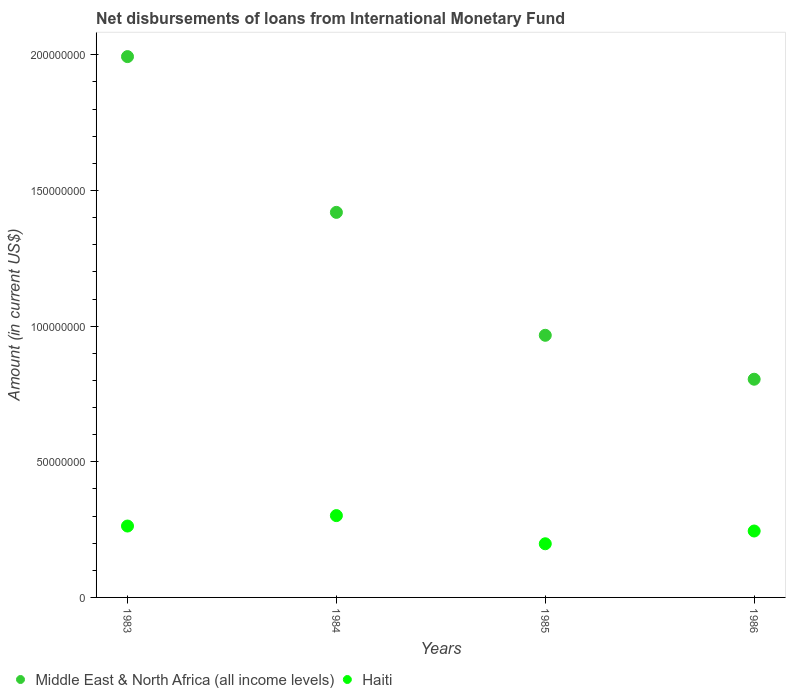Is the number of dotlines equal to the number of legend labels?
Keep it short and to the point. Yes. What is the amount of loans disbursed in Haiti in 1986?
Give a very brief answer. 2.45e+07. Across all years, what is the maximum amount of loans disbursed in Haiti?
Provide a short and direct response. 3.02e+07. Across all years, what is the minimum amount of loans disbursed in Haiti?
Offer a terse response. 1.98e+07. In which year was the amount of loans disbursed in Middle East & North Africa (all income levels) minimum?
Keep it short and to the point. 1986. What is the total amount of loans disbursed in Middle East & North Africa (all income levels) in the graph?
Make the answer very short. 5.18e+08. What is the difference between the amount of loans disbursed in Haiti in 1985 and that in 1986?
Offer a very short reply. -4.70e+06. What is the difference between the amount of loans disbursed in Middle East & North Africa (all income levels) in 1985 and the amount of loans disbursed in Haiti in 1983?
Offer a terse response. 7.03e+07. What is the average amount of loans disbursed in Haiti per year?
Provide a short and direct response. 2.52e+07. In the year 1985, what is the difference between the amount of loans disbursed in Middle East & North Africa (all income levels) and amount of loans disbursed in Haiti?
Provide a short and direct response. 7.68e+07. In how many years, is the amount of loans disbursed in Middle East & North Africa (all income levels) greater than 150000000 US$?
Provide a succinct answer. 1. What is the ratio of the amount of loans disbursed in Haiti in 1985 to that in 1986?
Provide a short and direct response. 0.81. Is the difference between the amount of loans disbursed in Middle East & North Africa (all income levels) in 1983 and 1985 greater than the difference between the amount of loans disbursed in Haiti in 1983 and 1985?
Make the answer very short. Yes. What is the difference between the highest and the second highest amount of loans disbursed in Middle East & North Africa (all income levels)?
Your answer should be very brief. 5.74e+07. What is the difference between the highest and the lowest amount of loans disbursed in Middle East & North Africa (all income levels)?
Keep it short and to the point. 1.19e+08. In how many years, is the amount of loans disbursed in Middle East & North Africa (all income levels) greater than the average amount of loans disbursed in Middle East & North Africa (all income levels) taken over all years?
Ensure brevity in your answer.  2. Is the amount of loans disbursed in Haiti strictly greater than the amount of loans disbursed in Middle East & North Africa (all income levels) over the years?
Provide a short and direct response. No. How many dotlines are there?
Your response must be concise. 2. Are the values on the major ticks of Y-axis written in scientific E-notation?
Provide a short and direct response. No. Where does the legend appear in the graph?
Your answer should be very brief. Bottom left. How are the legend labels stacked?
Provide a succinct answer. Horizontal. What is the title of the graph?
Keep it short and to the point. Net disbursements of loans from International Monetary Fund. What is the label or title of the Y-axis?
Your answer should be very brief. Amount (in current US$). What is the Amount (in current US$) of Middle East & North Africa (all income levels) in 1983?
Make the answer very short. 1.99e+08. What is the Amount (in current US$) of Haiti in 1983?
Give a very brief answer. 2.63e+07. What is the Amount (in current US$) in Middle East & North Africa (all income levels) in 1984?
Keep it short and to the point. 1.42e+08. What is the Amount (in current US$) of Haiti in 1984?
Your answer should be very brief. 3.02e+07. What is the Amount (in current US$) in Middle East & North Africa (all income levels) in 1985?
Your response must be concise. 9.66e+07. What is the Amount (in current US$) of Haiti in 1985?
Ensure brevity in your answer.  1.98e+07. What is the Amount (in current US$) of Middle East & North Africa (all income levels) in 1986?
Ensure brevity in your answer.  8.04e+07. What is the Amount (in current US$) of Haiti in 1986?
Provide a succinct answer. 2.45e+07. Across all years, what is the maximum Amount (in current US$) of Middle East & North Africa (all income levels)?
Offer a terse response. 1.99e+08. Across all years, what is the maximum Amount (in current US$) in Haiti?
Your answer should be compact. 3.02e+07. Across all years, what is the minimum Amount (in current US$) of Middle East & North Africa (all income levels)?
Make the answer very short. 8.04e+07. Across all years, what is the minimum Amount (in current US$) in Haiti?
Make the answer very short. 1.98e+07. What is the total Amount (in current US$) of Middle East & North Africa (all income levels) in the graph?
Provide a short and direct response. 5.18e+08. What is the total Amount (in current US$) of Haiti in the graph?
Your answer should be compact. 1.01e+08. What is the difference between the Amount (in current US$) of Middle East & North Africa (all income levels) in 1983 and that in 1984?
Your response must be concise. 5.74e+07. What is the difference between the Amount (in current US$) in Haiti in 1983 and that in 1984?
Ensure brevity in your answer.  -3.85e+06. What is the difference between the Amount (in current US$) of Middle East & North Africa (all income levels) in 1983 and that in 1985?
Provide a succinct answer. 1.03e+08. What is the difference between the Amount (in current US$) of Haiti in 1983 and that in 1985?
Provide a short and direct response. 6.54e+06. What is the difference between the Amount (in current US$) of Middle East & North Africa (all income levels) in 1983 and that in 1986?
Your answer should be very brief. 1.19e+08. What is the difference between the Amount (in current US$) in Haiti in 1983 and that in 1986?
Make the answer very short. 1.83e+06. What is the difference between the Amount (in current US$) of Middle East & North Africa (all income levels) in 1984 and that in 1985?
Give a very brief answer. 4.53e+07. What is the difference between the Amount (in current US$) in Haiti in 1984 and that in 1985?
Provide a short and direct response. 1.04e+07. What is the difference between the Amount (in current US$) in Middle East & North Africa (all income levels) in 1984 and that in 1986?
Give a very brief answer. 6.15e+07. What is the difference between the Amount (in current US$) in Haiti in 1984 and that in 1986?
Ensure brevity in your answer.  5.68e+06. What is the difference between the Amount (in current US$) in Middle East & North Africa (all income levels) in 1985 and that in 1986?
Your response must be concise. 1.62e+07. What is the difference between the Amount (in current US$) in Haiti in 1985 and that in 1986?
Provide a short and direct response. -4.70e+06. What is the difference between the Amount (in current US$) in Middle East & North Africa (all income levels) in 1983 and the Amount (in current US$) in Haiti in 1984?
Your answer should be compact. 1.69e+08. What is the difference between the Amount (in current US$) in Middle East & North Africa (all income levels) in 1983 and the Amount (in current US$) in Haiti in 1985?
Provide a succinct answer. 1.80e+08. What is the difference between the Amount (in current US$) in Middle East & North Africa (all income levels) in 1983 and the Amount (in current US$) in Haiti in 1986?
Keep it short and to the point. 1.75e+08. What is the difference between the Amount (in current US$) in Middle East & North Africa (all income levels) in 1984 and the Amount (in current US$) in Haiti in 1985?
Make the answer very short. 1.22e+08. What is the difference between the Amount (in current US$) in Middle East & North Africa (all income levels) in 1984 and the Amount (in current US$) in Haiti in 1986?
Your answer should be compact. 1.17e+08. What is the difference between the Amount (in current US$) of Middle East & North Africa (all income levels) in 1985 and the Amount (in current US$) of Haiti in 1986?
Make the answer very short. 7.21e+07. What is the average Amount (in current US$) in Middle East & North Africa (all income levels) per year?
Your answer should be compact. 1.30e+08. What is the average Amount (in current US$) in Haiti per year?
Ensure brevity in your answer.  2.52e+07. In the year 1983, what is the difference between the Amount (in current US$) of Middle East & North Africa (all income levels) and Amount (in current US$) of Haiti?
Ensure brevity in your answer.  1.73e+08. In the year 1984, what is the difference between the Amount (in current US$) in Middle East & North Africa (all income levels) and Amount (in current US$) in Haiti?
Offer a very short reply. 1.12e+08. In the year 1985, what is the difference between the Amount (in current US$) in Middle East & North Africa (all income levels) and Amount (in current US$) in Haiti?
Keep it short and to the point. 7.68e+07. In the year 1986, what is the difference between the Amount (in current US$) of Middle East & North Africa (all income levels) and Amount (in current US$) of Haiti?
Your response must be concise. 5.60e+07. What is the ratio of the Amount (in current US$) in Middle East & North Africa (all income levels) in 1983 to that in 1984?
Your answer should be compact. 1.4. What is the ratio of the Amount (in current US$) of Haiti in 1983 to that in 1984?
Your answer should be very brief. 0.87. What is the ratio of the Amount (in current US$) in Middle East & North Africa (all income levels) in 1983 to that in 1985?
Your answer should be compact. 2.06. What is the ratio of the Amount (in current US$) in Haiti in 1983 to that in 1985?
Provide a succinct answer. 1.33. What is the ratio of the Amount (in current US$) in Middle East & North Africa (all income levels) in 1983 to that in 1986?
Make the answer very short. 2.48. What is the ratio of the Amount (in current US$) in Haiti in 1983 to that in 1986?
Provide a succinct answer. 1.07. What is the ratio of the Amount (in current US$) of Middle East & North Africa (all income levels) in 1984 to that in 1985?
Provide a succinct answer. 1.47. What is the ratio of the Amount (in current US$) of Haiti in 1984 to that in 1985?
Ensure brevity in your answer.  1.52. What is the ratio of the Amount (in current US$) in Middle East & North Africa (all income levels) in 1984 to that in 1986?
Provide a short and direct response. 1.76. What is the ratio of the Amount (in current US$) in Haiti in 1984 to that in 1986?
Offer a terse response. 1.23. What is the ratio of the Amount (in current US$) of Middle East & North Africa (all income levels) in 1985 to that in 1986?
Your answer should be very brief. 1.2. What is the ratio of the Amount (in current US$) in Haiti in 1985 to that in 1986?
Offer a very short reply. 0.81. What is the difference between the highest and the second highest Amount (in current US$) in Middle East & North Africa (all income levels)?
Ensure brevity in your answer.  5.74e+07. What is the difference between the highest and the second highest Amount (in current US$) of Haiti?
Ensure brevity in your answer.  3.85e+06. What is the difference between the highest and the lowest Amount (in current US$) of Middle East & North Africa (all income levels)?
Keep it short and to the point. 1.19e+08. What is the difference between the highest and the lowest Amount (in current US$) of Haiti?
Your answer should be compact. 1.04e+07. 